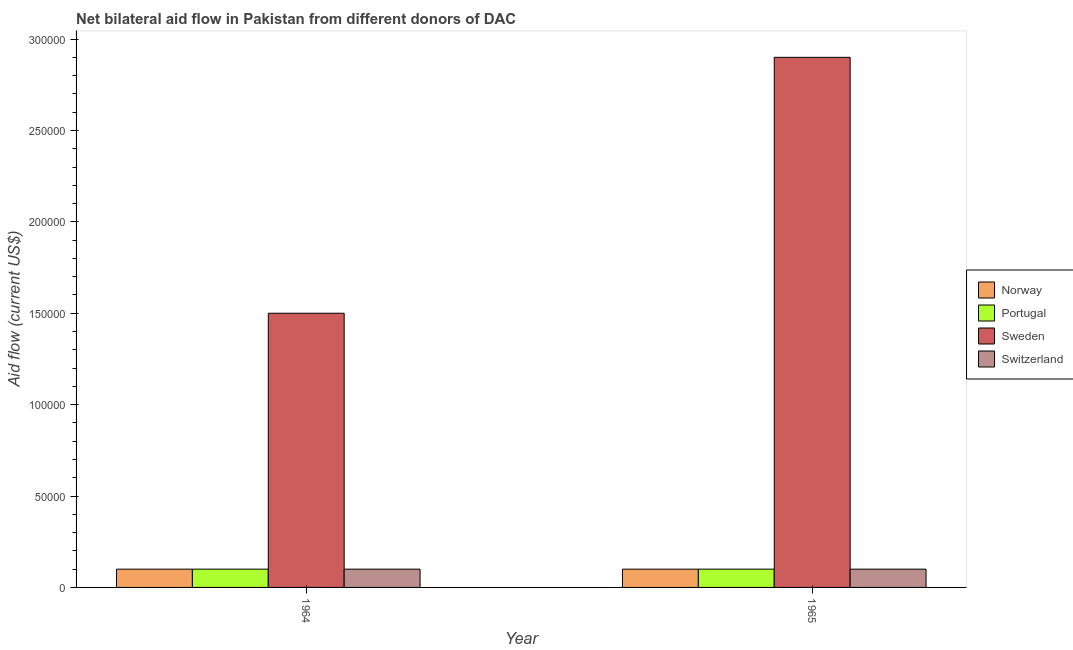Are the number of bars per tick equal to the number of legend labels?
Give a very brief answer. Yes. How many bars are there on the 2nd tick from the left?
Your answer should be very brief. 4. How many bars are there on the 2nd tick from the right?
Your answer should be very brief. 4. What is the label of the 1st group of bars from the left?
Provide a short and direct response. 1964. In how many cases, is the number of bars for a given year not equal to the number of legend labels?
Give a very brief answer. 0. What is the amount of aid given by portugal in 1965?
Make the answer very short. 10000. Across all years, what is the maximum amount of aid given by sweden?
Make the answer very short. 2.90e+05. Across all years, what is the minimum amount of aid given by norway?
Your answer should be compact. 10000. In which year was the amount of aid given by switzerland maximum?
Provide a succinct answer. 1964. In which year was the amount of aid given by norway minimum?
Offer a very short reply. 1964. What is the total amount of aid given by switzerland in the graph?
Give a very brief answer. 2.00e+04. What is the difference between the amount of aid given by switzerland in 1964 and the amount of aid given by norway in 1965?
Make the answer very short. 0. In the year 1965, what is the difference between the amount of aid given by sweden and amount of aid given by norway?
Your answer should be compact. 0. In how many years, is the amount of aid given by portugal greater than 20000 US$?
Offer a terse response. 0. What is the ratio of the amount of aid given by switzerland in 1964 to that in 1965?
Provide a short and direct response. 1. Is the amount of aid given by portugal in 1964 less than that in 1965?
Your answer should be very brief. No. In how many years, is the amount of aid given by switzerland greater than the average amount of aid given by switzerland taken over all years?
Give a very brief answer. 0. Is it the case that in every year, the sum of the amount of aid given by switzerland and amount of aid given by norway is greater than the sum of amount of aid given by portugal and amount of aid given by sweden?
Ensure brevity in your answer.  No. What does the 3rd bar from the left in 1964 represents?
Offer a very short reply. Sweden. What does the 2nd bar from the right in 1965 represents?
Offer a terse response. Sweden. How many bars are there?
Ensure brevity in your answer.  8. Are all the bars in the graph horizontal?
Your answer should be compact. No. Are the values on the major ticks of Y-axis written in scientific E-notation?
Your answer should be compact. No. Does the graph contain grids?
Your answer should be compact. No. Where does the legend appear in the graph?
Ensure brevity in your answer.  Center right. How many legend labels are there?
Your answer should be very brief. 4. What is the title of the graph?
Keep it short and to the point. Net bilateral aid flow in Pakistan from different donors of DAC. What is the Aid flow (current US$) of Norway in 1964?
Your answer should be compact. 10000. What is the Aid flow (current US$) in Sweden in 1964?
Make the answer very short. 1.50e+05. What is the Aid flow (current US$) in Norway in 1965?
Your answer should be very brief. 10000. What is the Aid flow (current US$) in Sweden in 1965?
Your answer should be very brief. 2.90e+05. Across all years, what is the maximum Aid flow (current US$) in Sweden?
Offer a very short reply. 2.90e+05. Across all years, what is the maximum Aid flow (current US$) in Switzerland?
Keep it short and to the point. 10000. Across all years, what is the minimum Aid flow (current US$) of Norway?
Provide a short and direct response. 10000. Across all years, what is the minimum Aid flow (current US$) of Sweden?
Your answer should be compact. 1.50e+05. What is the total Aid flow (current US$) in Norway in the graph?
Your answer should be compact. 2.00e+04. What is the total Aid flow (current US$) in Portugal in the graph?
Your answer should be compact. 2.00e+04. What is the difference between the Aid flow (current US$) in Portugal in 1964 and that in 1965?
Provide a succinct answer. 0. What is the difference between the Aid flow (current US$) in Switzerland in 1964 and that in 1965?
Give a very brief answer. 0. What is the difference between the Aid flow (current US$) in Norway in 1964 and the Aid flow (current US$) in Portugal in 1965?
Your response must be concise. 0. What is the difference between the Aid flow (current US$) of Norway in 1964 and the Aid flow (current US$) of Sweden in 1965?
Your response must be concise. -2.80e+05. What is the difference between the Aid flow (current US$) in Portugal in 1964 and the Aid flow (current US$) in Sweden in 1965?
Provide a short and direct response. -2.80e+05. What is the difference between the Aid flow (current US$) of Sweden in 1964 and the Aid flow (current US$) of Switzerland in 1965?
Offer a terse response. 1.40e+05. What is the average Aid flow (current US$) in Portugal per year?
Your answer should be very brief. 10000. What is the average Aid flow (current US$) of Sweden per year?
Offer a terse response. 2.20e+05. What is the average Aid flow (current US$) of Switzerland per year?
Your answer should be very brief. 10000. In the year 1964, what is the difference between the Aid flow (current US$) in Norway and Aid flow (current US$) in Sweden?
Your answer should be compact. -1.40e+05. In the year 1964, what is the difference between the Aid flow (current US$) of Portugal and Aid flow (current US$) of Switzerland?
Ensure brevity in your answer.  0. In the year 1964, what is the difference between the Aid flow (current US$) in Sweden and Aid flow (current US$) in Switzerland?
Your response must be concise. 1.40e+05. In the year 1965, what is the difference between the Aid flow (current US$) of Norway and Aid flow (current US$) of Sweden?
Provide a short and direct response. -2.80e+05. In the year 1965, what is the difference between the Aid flow (current US$) in Norway and Aid flow (current US$) in Switzerland?
Provide a succinct answer. 0. In the year 1965, what is the difference between the Aid flow (current US$) in Portugal and Aid flow (current US$) in Sweden?
Keep it short and to the point. -2.80e+05. In the year 1965, what is the difference between the Aid flow (current US$) in Portugal and Aid flow (current US$) in Switzerland?
Your answer should be compact. 0. In the year 1965, what is the difference between the Aid flow (current US$) of Sweden and Aid flow (current US$) of Switzerland?
Your answer should be very brief. 2.80e+05. What is the ratio of the Aid flow (current US$) of Norway in 1964 to that in 1965?
Your answer should be compact. 1. What is the ratio of the Aid flow (current US$) of Sweden in 1964 to that in 1965?
Offer a very short reply. 0.52. What is the ratio of the Aid flow (current US$) in Switzerland in 1964 to that in 1965?
Your answer should be very brief. 1. What is the difference between the highest and the second highest Aid flow (current US$) in Norway?
Keep it short and to the point. 0. What is the difference between the highest and the second highest Aid flow (current US$) of Portugal?
Keep it short and to the point. 0. What is the difference between the highest and the second highest Aid flow (current US$) in Sweden?
Keep it short and to the point. 1.40e+05. What is the difference between the highest and the second highest Aid flow (current US$) of Switzerland?
Provide a short and direct response. 0. 